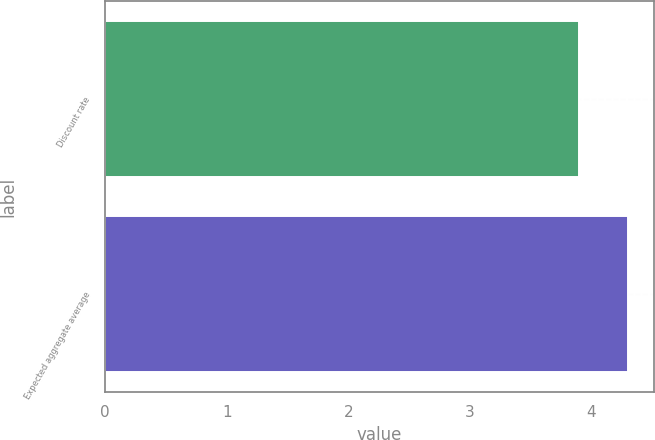<chart> <loc_0><loc_0><loc_500><loc_500><bar_chart><fcel>Discount rate<fcel>Expected aggregate average<nl><fcel>3.9<fcel>4.3<nl></chart> 